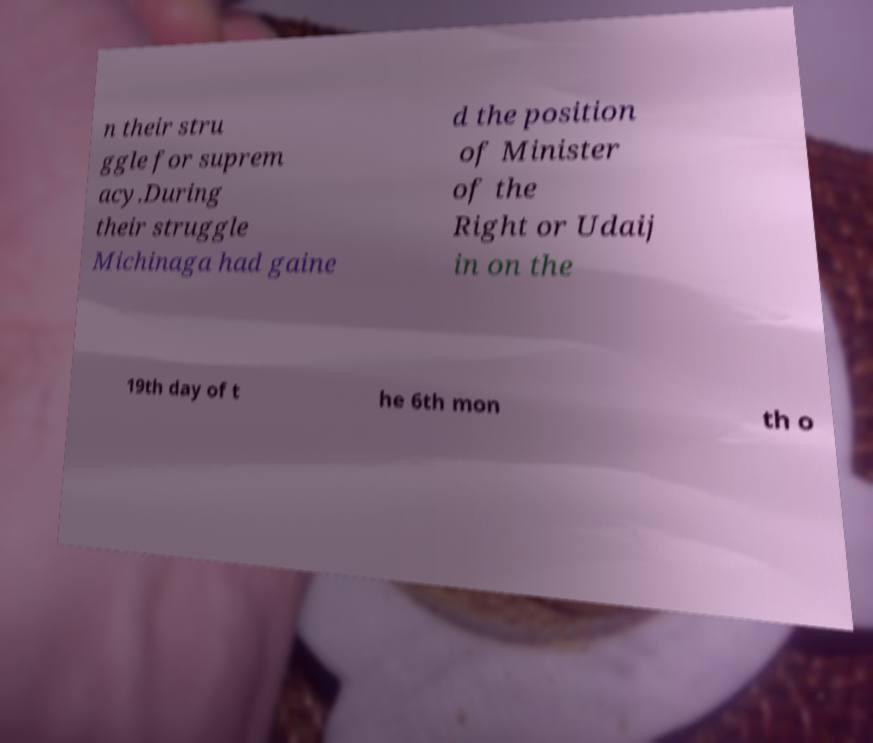Please read and relay the text visible in this image. What does it say? n their stru ggle for suprem acy.During their struggle Michinaga had gaine d the position of Minister of the Right or Udaij in on the 19th day of t he 6th mon th o 